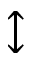Convert formula to latex. <formula><loc_0><loc_0><loc_500><loc_500>\updownarrow</formula> 